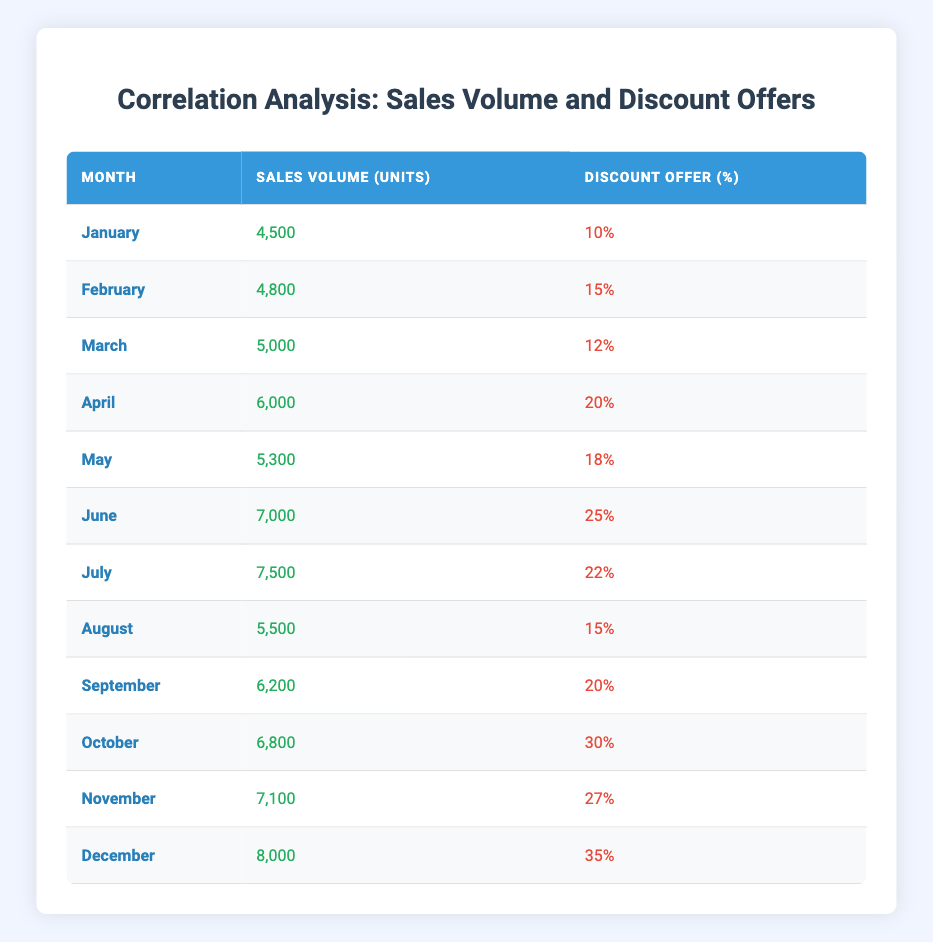What month had the highest sales volume? Looking at the 'Sales Volume (Units)' column, December has the highest value at 8,000 units.
Answer: December What was the discount offer percentage in July? Directly referencing the 'Discount Offer (%)' column, the percentage for July is 22%.
Answer: 22% How many total units were sold from January to April? Summing the sales volumes from January (4,500), February (4,800), March (5,000), and April (6,000) gives a total of 4,500 + 4,800 + 5,000 + 6,000 = 20,300 units.
Answer: 20,300 Is it true that every month with a discount offer above 20% saw sales volume over 6,000 units? Analyzing the rows where the discount offer is above 20%: June (7,000), July (7,500), October (6,800), November (7,100), and December (8,000) all indeed have sales volumes over 6,000 units. Therefore, the statement is true.
Answer: Yes What is the average discount offer for the last three months of the year? The last three months are October (30%), November (27%), and December (35%). Their average is (30 + 27 + 35) / 3 = 92 / 3 = 30.67%.
Answer: 30.67% How much did sales volume increase from September to October? The sales volume in September is 6,200 units, and in October it's 6,800 units. The increase is 6,800 - 6,200 = 600 units.
Answer: 600 What was the total sales volume across all months with a discount offer of 15% or less? The months January (4,500), March (5,000), and August (5,500) have discount offers of 15% or less. Summing these gives 4,500 + 5,000 + 5,500 = 15,000 units.
Answer: 15,000 Which month showed the largest percentage increase in sales volume compared to the previous month? Comparing the monthly sales volumes, December (8,000) compared to November (7,100) shows an increase of (8,000 - 7,100) / 7,100 * 100% = 12.68%. However, the largest month-to-month increase in units is from October (6,800) to November (7,100), which is 300 units (4.41%). Hence, the largest unit increase is from October to November with the percentage increase from September to October (600/6200 * 100% = 9.68%).
Answer: October to November 